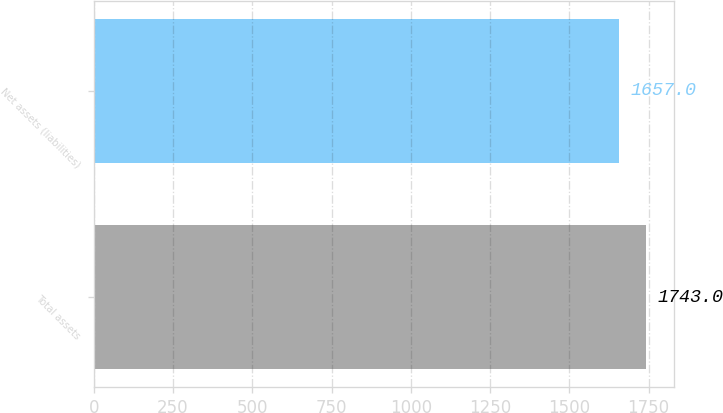<chart> <loc_0><loc_0><loc_500><loc_500><bar_chart><fcel>Total assets<fcel>Net assets (liabilities)<nl><fcel>1743<fcel>1657<nl></chart> 